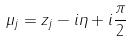Convert formula to latex. <formula><loc_0><loc_0><loc_500><loc_500>\mu _ { j } = z _ { j } - i \eta + i \frac { \pi } { 2 }</formula> 